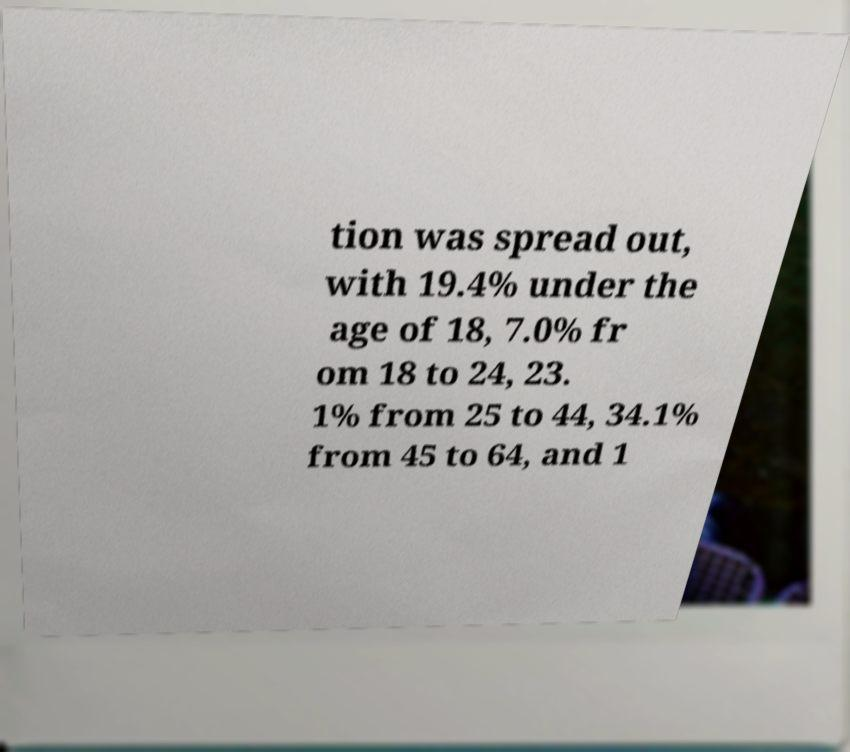Please read and relay the text visible in this image. What does it say? tion was spread out, with 19.4% under the age of 18, 7.0% fr om 18 to 24, 23. 1% from 25 to 44, 34.1% from 45 to 64, and 1 